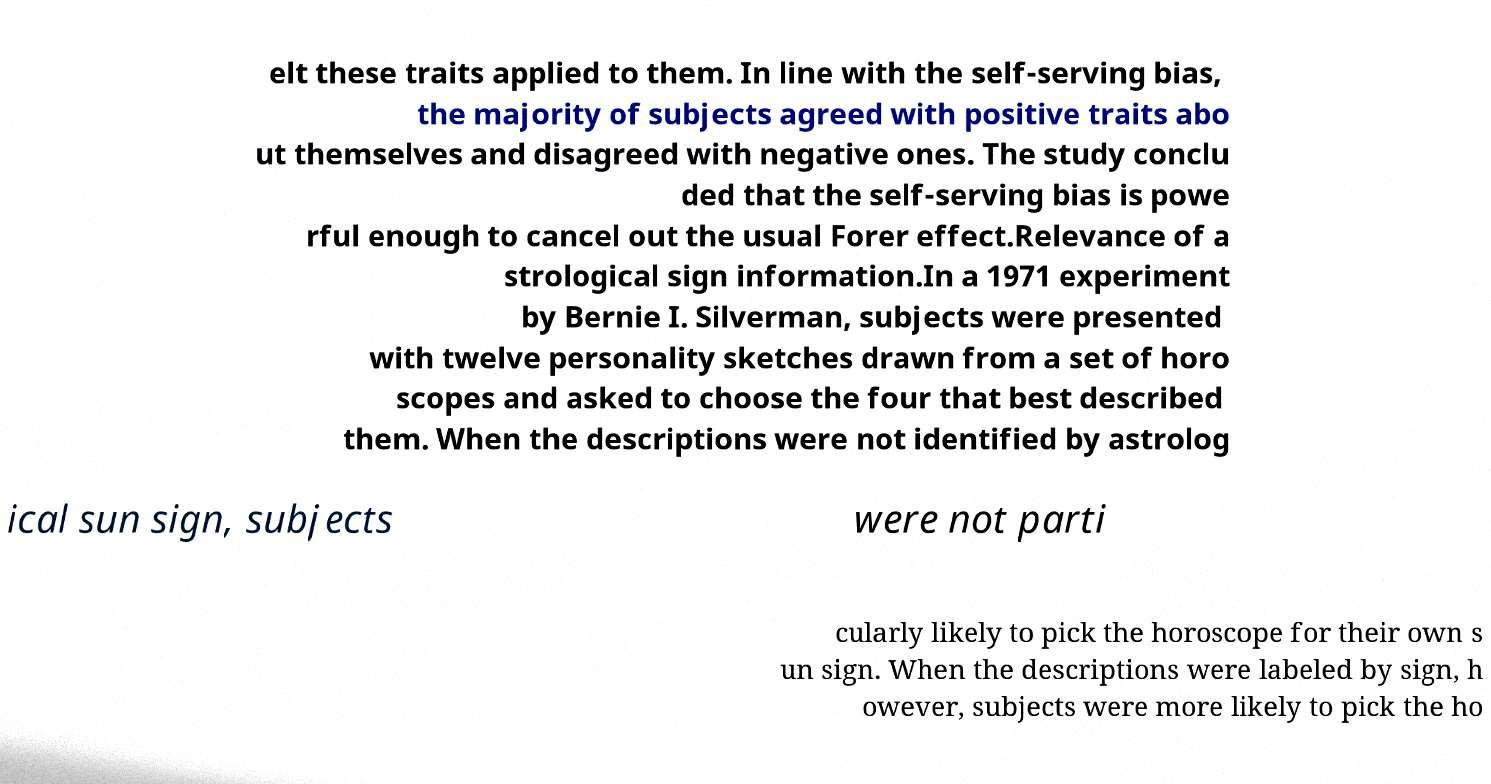For documentation purposes, I need the text within this image transcribed. Could you provide that? elt these traits applied to them. In line with the self-serving bias, the majority of subjects agreed with positive traits abo ut themselves and disagreed with negative ones. The study conclu ded that the self-serving bias is powe rful enough to cancel out the usual Forer effect.Relevance of a strological sign information.In a 1971 experiment by Bernie I. Silverman, subjects were presented with twelve personality sketches drawn from a set of horo scopes and asked to choose the four that best described them. When the descriptions were not identified by astrolog ical sun sign, subjects were not parti cularly likely to pick the horoscope for their own s un sign. When the descriptions were labeled by sign, h owever, subjects were more likely to pick the ho 